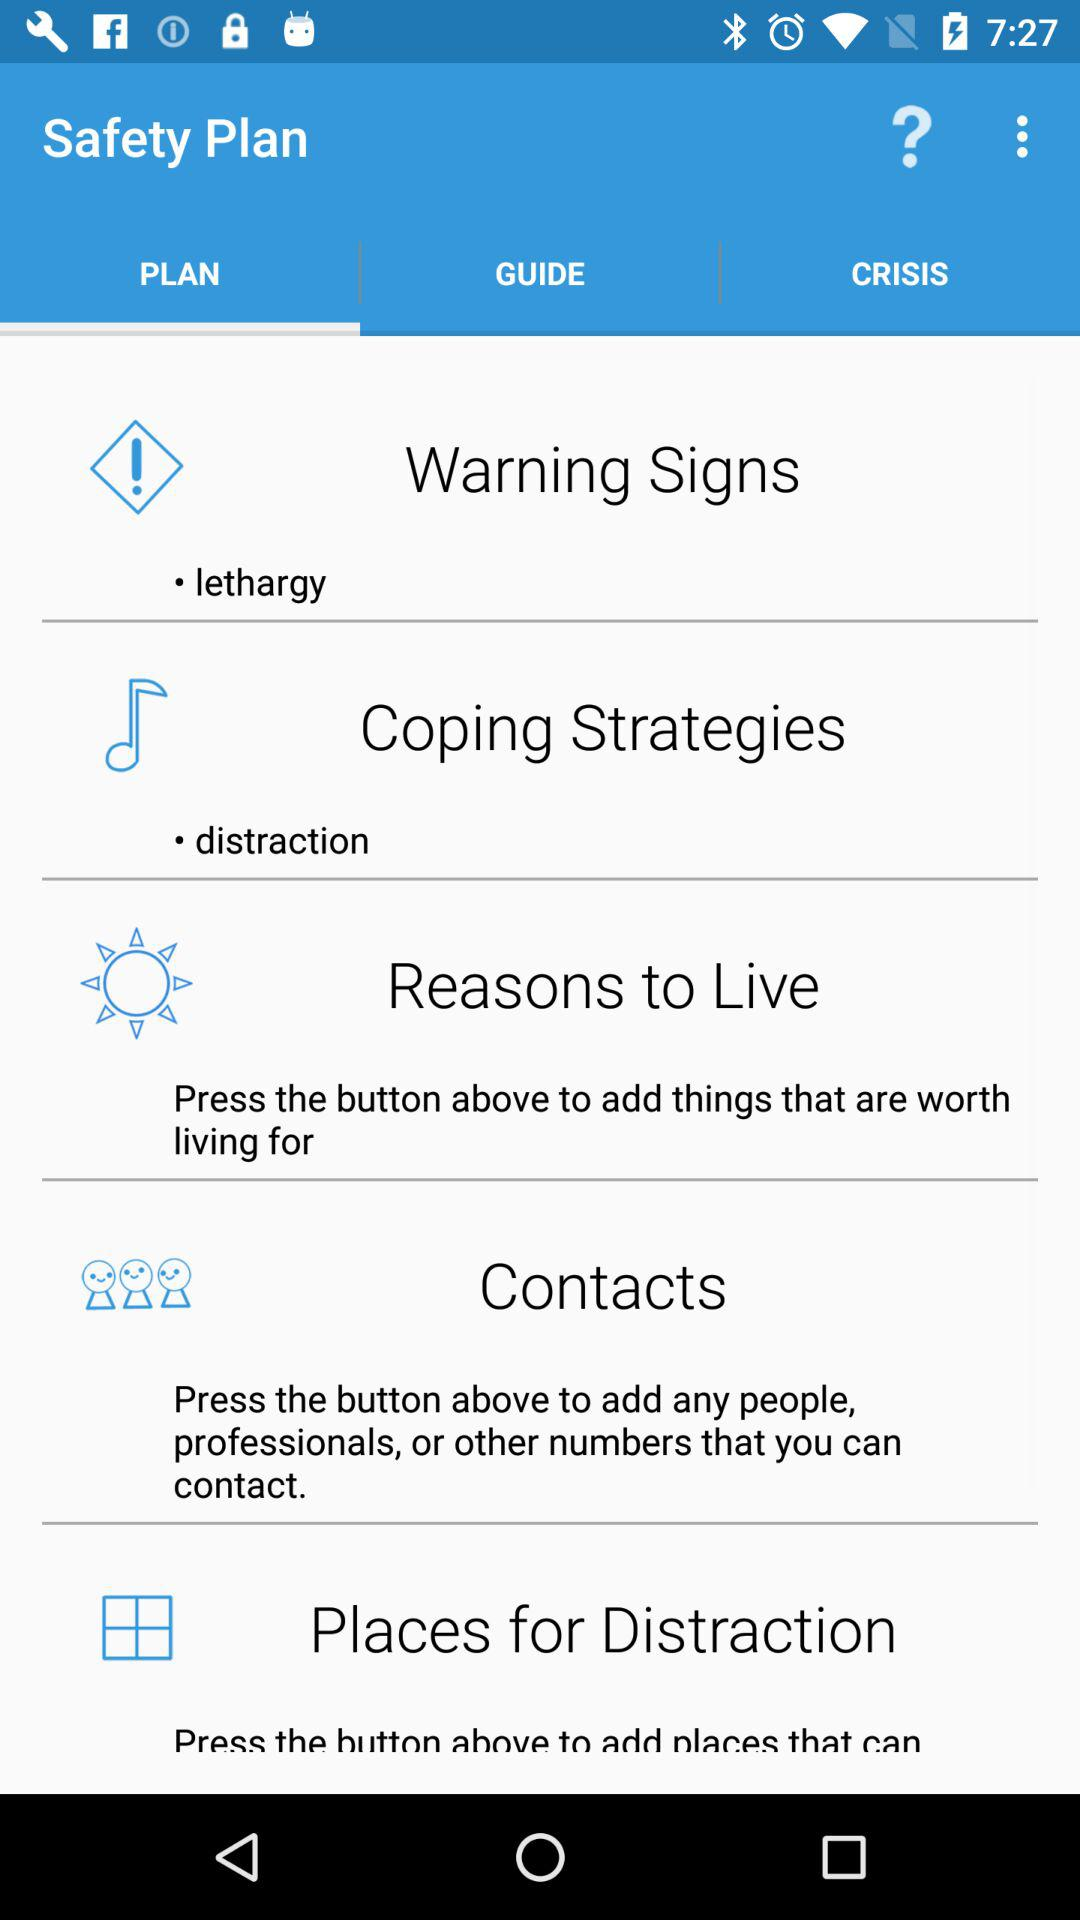How many items are in the safety plan?
Answer the question using a single word or phrase. 5 